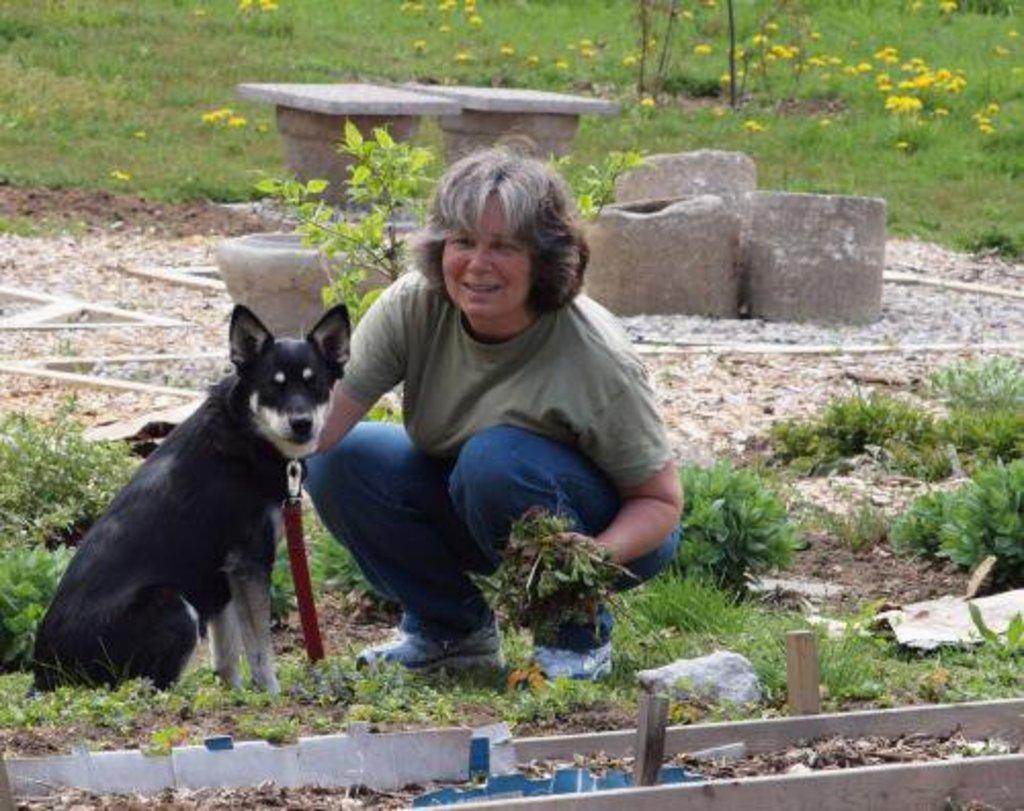In one or two sentences, can you explain what this image depicts? In this image we can see a person holding something in the hand. There is a dog with a belt. On the ground there are plants. Also there are stones. 